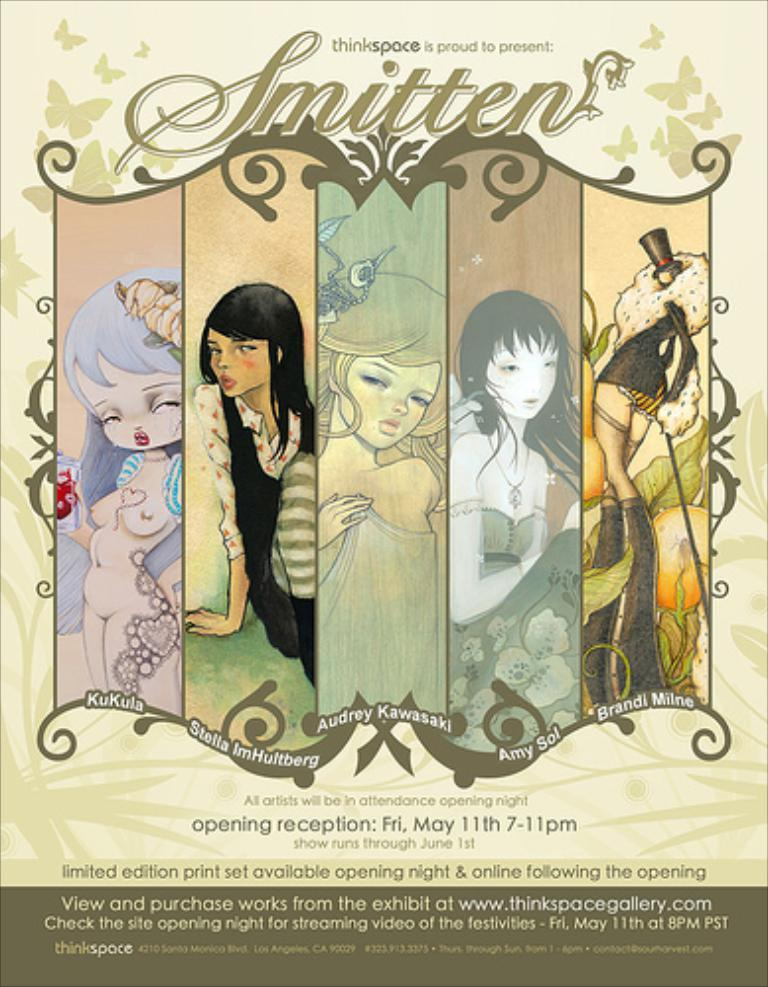What is present on the poster in the image? There is a poster in the image. What can be found on the poster besides text? The poster contains images. What type of information is conveyed on the poster? The poster contains text. How many oranges are hanging from the poster in the image? There are no oranges present on or hanging from the poster in the image. Is there a light bulb visible on the poster in the image? There is no light bulb visible on the poster in the image. 